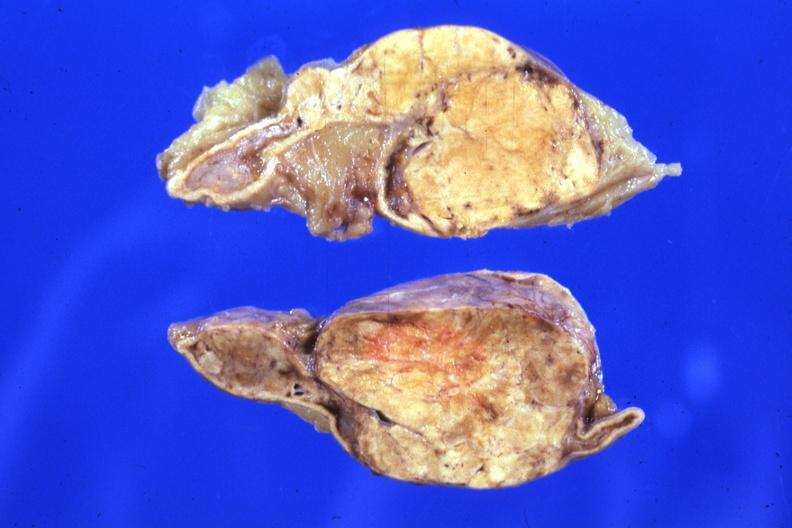s cortical nodule present?
Answer the question using a single word or phrase. Yes 